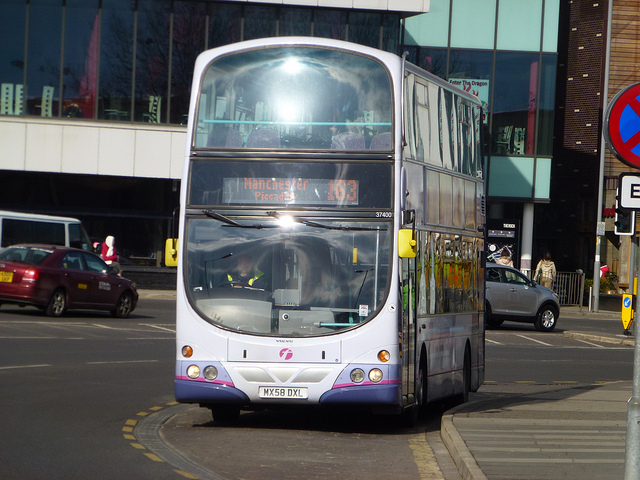Read all the text in this image. Manchester 183 37400 MX58 OXL 